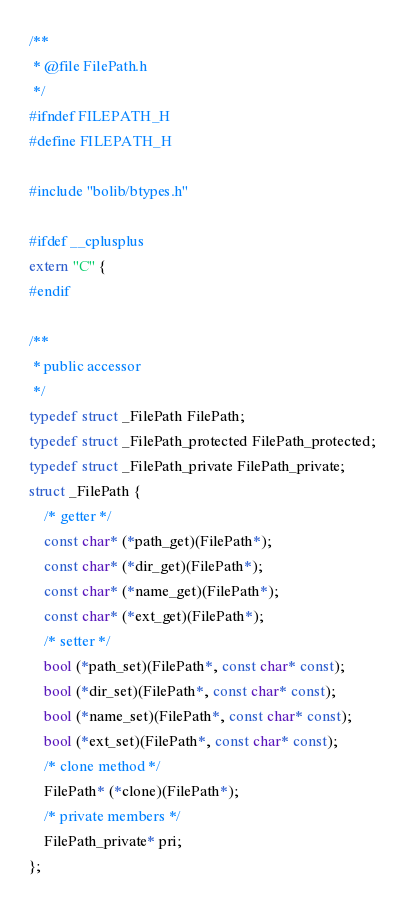Convert code to text. <code><loc_0><loc_0><loc_500><loc_500><_C_>/**
 * @file FilePath.h
 */
#ifndef FILEPATH_H
#define FILEPATH_H

#include "bolib/btypes.h"

#ifdef __cplusplus
extern "C" {
#endif

/**
 * public accessor
 */
typedef struct _FilePath FilePath;
typedef struct _FilePath_protected FilePath_protected;
typedef struct _FilePath_private FilePath_private;
struct _FilePath {
	/* getter */
	const char* (*path_get)(FilePath*);
	const char* (*dir_get)(FilePath*);
	const char* (*name_get)(FilePath*);
	const char* (*ext_get)(FilePath*);
	/* setter */
	bool (*path_set)(FilePath*, const char* const);
	bool (*dir_set)(FilePath*, const char* const);
	bool (*name_set)(FilePath*, const char* const);
	bool (*ext_set)(FilePath*, const char* const);
	/* clone method */
	FilePath* (*clone)(FilePath*);
	/* private members */
	FilePath_private* pri;
};
</code> 